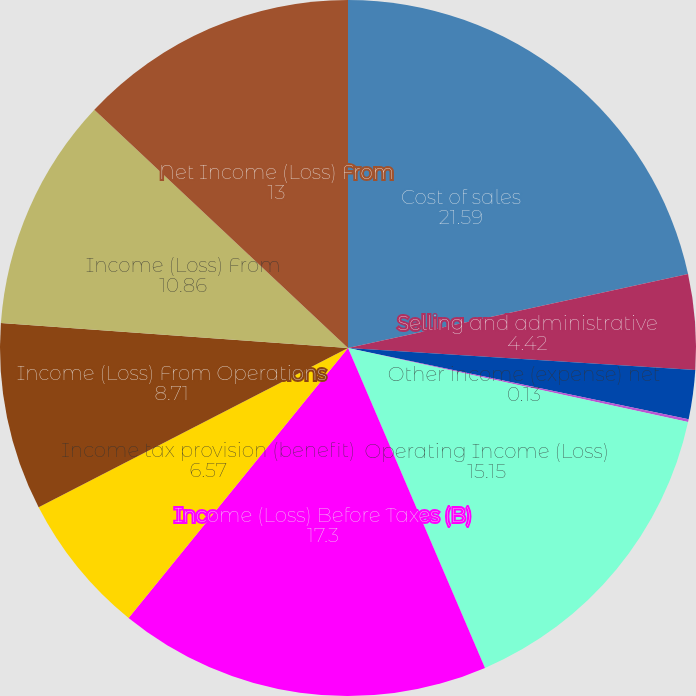Convert chart to OTSL. <chart><loc_0><loc_0><loc_500><loc_500><pie_chart><fcel>Cost of sales<fcel>Selling and administrative<fcel>Research and development<fcel>Other income (expense) net<fcel>Operating Income (Loss)<fcel>Income (Loss) Before Taxes (B)<fcel>Income tax provision (benefit)<fcel>Income (Loss) From Operations<fcel>Income (Loss) From<fcel>Net Income (Loss) From<nl><fcel>21.59%<fcel>4.42%<fcel>2.27%<fcel>0.13%<fcel>15.15%<fcel>17.3%<fcel>6.57%<fcel>8.71%<fcel>10.86%<fcel>13.0%<nl></chart> 